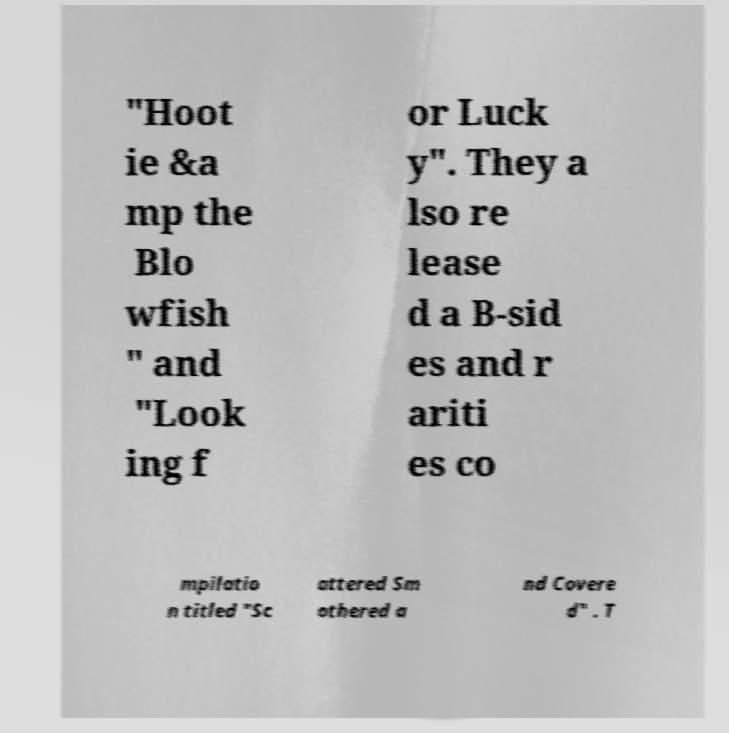Could you assist in decoding the text presented in this image and type it out clearly? "Hoot ie &a mp the Blo wfish " and "Look ing f or Luck y". They a lso re lease d a B-sid es and r ariti es co mpilatio n titled "Sc attered Sm othered a nd Covere d" . T 